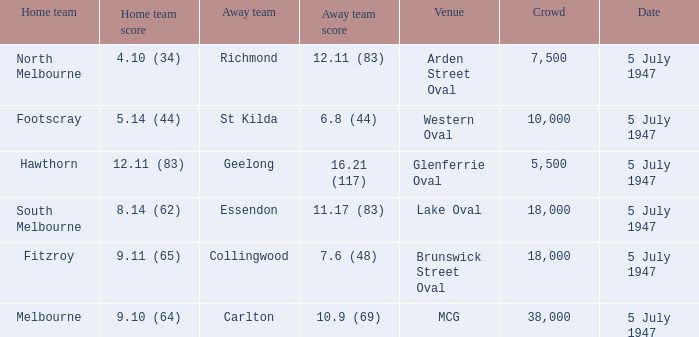Where was the game played where the away team has a score of 7.6 (48)? Brunswick Street Oval. 